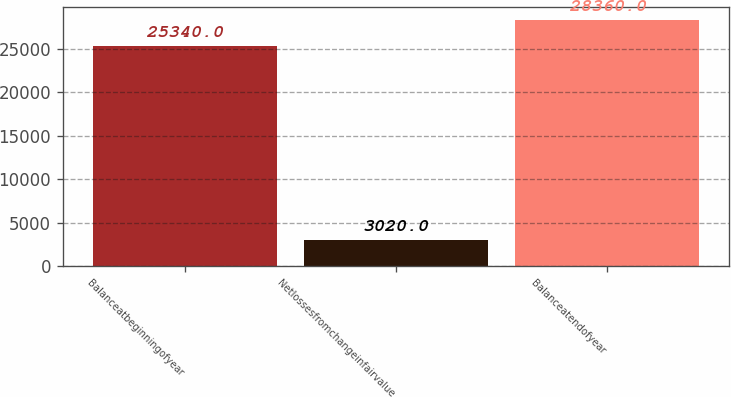Convert chart. <chart><loc_0><loc_0><loc_500><loc_500><bar_chart><fcel>Balanceatbeginningofyear<fcel>Netlossesfromchangeinfairvalue<fcel>Balanceatendofyear<nl><fcel>25340<fcel>3020<fcel>28360<nl></chart> 